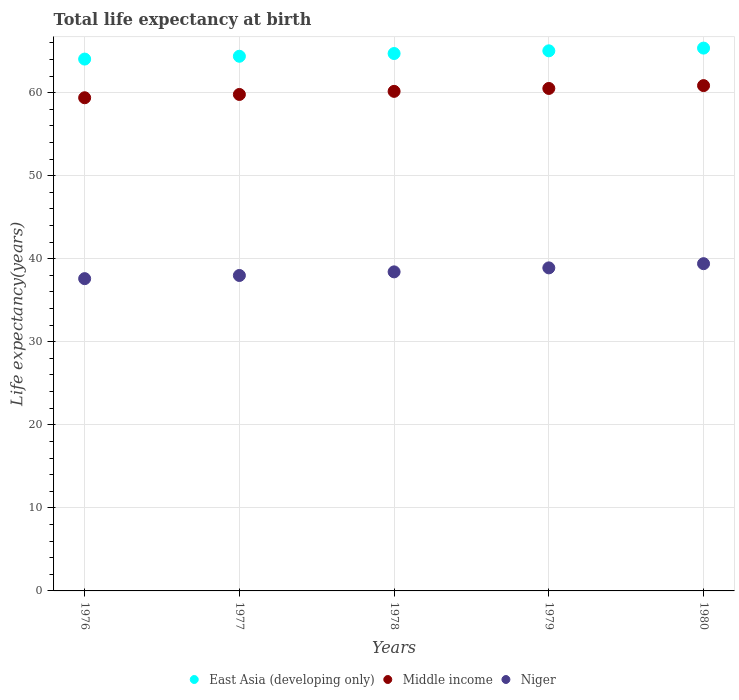Is the number of dotlines equal to the number of legend labels?
Your answer should be very brief. Yes. What is the life expectancy at birth in in Niger in 1979?
Give a very brief answer. 38.9. Across all years, what is the maximum life expectancy at birth in in Middle income?
Your response must be concise. 60.85. Across all years, what is the minimum life expectancy at birth in in Middle income?
Your response must be concise. 59.38. In which year was the life expectancy at birth in in Middle income maximum?
Your answer should be compact. 1980. In which year was the life expectancy at birth in in Middle income minimum?
Offer a very short reply. 1976. What is the total life expectancy at birth in in East Asia (developing only) in the graph?
Keep it short and to the point. 323.53. What is the difference between the life expectancy at birth in in East Asia (developing only) in 1979 and that in 1980?
Offer a very short reply. -0.33. What is the difference between the life expectancy at birth in in Middle income in 1978 and the life expectancy at birth in in East Asia (developing only) in 1976?
Your response must be concise. -3.89. What is the average life expectancy at birth in in Niger per year?
Offer a terse response. 38.46. In the year 1977, what is the difference between the life expectancy at birth in in East Asia (developing only) and life expectancy at birth in in Niger?
Offer a very short reply. 26.4. What is the ratio of the life expectancy at birth in in East Asia (developing only) in 1976 to that in 1978?
Keep it short and to the point. 0.99. Is the life expectancy at birth in in Niger in 1978 less than that in 1979?
Provide a short and direct response. Yes. What is the difference between the highest and the second highest life expectancy at birth in in Middle income?
Offer a terse response. 0.34. What is the difference between the highest and the lowest life expectancy at birth in in Niger?
Give a very brief answer. 1.8. Is the sum of the life expectancy at birth in in East Asia (developing only) in 1977 and 1978 greater than the maximum life expectancy at birth in in Middle income across all years?
Ensure brevity in your answer.  Yes. Does the life expectancy at birth in in Middle income monotonically increase over the years?
Offer a terse response. Yes. Is the life expectancy at birth in in Middle income strictly less than the life expectancy at birth in in East Asia (developing only) over the years?
Offer a very short reply. Yes. How many dotlines are there?
Your answer should be very brief. 3. Does the graph contain any zero values?
Keep it short and to the point. No. Does the graph contain grids?
Provide a short and direct response. Yes. How are the legend labels stacked?
Keep it short and to the point. Horizontal. What is the title of the graph?
Your answer should be very brief. Total life expectancy at birth. Does "Philippines" appear as one of the legend labels in the graph?
Provide a short and direct response. No. What is the label or title of the X-axis?
Provide a succinct answer. Years. What is the label or title of the Y-axis?
Give a very brief answer. Life expectancy(years). What is the Life expectancy(years) of East Asia (developing only) in 1976?
Offer a terse response. 64.04. What is the Life expectancy(years) of Middle income in 1976?
Give a very brief answer. 59.38. What is the Life expectancy(years) of Niger in 1976?
Your answer should be compact. 37.6. What is the Life expectancy(years) in East Asia (developing only) in 1977?
Make the answer very short. 64.38. What is the Life expectancy(years) of Middle income in 1977?
Your response must be concise. 59.78. What is the Life expectancy(years) of Niger in 1977?
Make the answer very short. 37.98. What is the Life expectancy(years) in East Asia (developing only) in 1978?
Give a very brief answer. 64.71. What is the Life expectancy(years) in Middle income in 1978?
Keep it short and to the point. 60.15. What is the Life expectancy(years) of Niger in 1978?
Provide a short and direct response. 38.42. What is the Life expectancy(years) in East Asia (developing only) in 1979?
Provide a short and direct response. 65.03. What is the Life expectancy(years) in Middle income in 1979?
Make the answer very short. 60.5. What is the Life expectancy(years) of Niger in 1979?
Your answer should be compact. 38.9. What is the Life expectancy(years) in East Asia (developing only) in 1980?
Your response must be concise. 65.36. What is the Life expectancy(years) of Middle income in 1980?
Your answer should be compact. 60.85. What is the Life expectancy(years) of Niger in 1980?
Make the answer very short. 39.4. Across all years, what is the maximum Life expectancy(years) in East Asia (developing only)?
Provide a succinct answer. 65.36. Across all years, what is the maximum Life expectancy(years) of Middle income?
Keep it short and to the point. 60.85. Across all years, what is the maximum Life expectancy(years) of Niger?
Give a very brief answer. 39.4. Across all years, what is the minimum Life expectancy(years) in East Asia (developing only)?
Your answer should be very brief. 64.04. Across all years, what is the minimum Life expectancy(years) of Middle income?
Give a very brief answer. 59.38. Across all years, what is the minimum Life expectancy(years) in Niger?
Make the answer very short. 37.6. What is the total Life expectancy(years) in East Asia (developing only) in the graph?
Ensure brevity in your answer.  323.53. What is the total Life expectancy(years) of Middle income in the graph?
Your answer should be compact. 300.67. What is the total Life expectancy(years) of Niger in the graph?
Make the answer very short. 192.3. What is the difference between the Life expectancy(years) in East Asia (developing only) in 1976 and that in 1977?
Your response must be concise. -0.34. What is the difference between the Life expectancy(years) of Middle income in 1976 and that in 1977?
Your response must be concise. -0.4. What is the difference between the Life expectancy(years) of Niger in 1976 and that in 1977?
Your answer should be very brief. -0.38. What is the difference between the Life expectancy(years) in East Asia (developing only) in 1976 and that in 1978?
Offer a very short reply. -0.67. What is the difference between the Life expectancy(years) of Middle income in 1976 and that in 1978?
Ensure brevity in your answer.  -0.77. What is the difference between the Life expectancy(years) of Niger in 1976 and that in 1978?
Provide a succinct answer. -0.82. What is the difference between the Life expectancy(years) of East Asia (developing only) in 1976 and that in 1979?
Offer a terse response. -0.99. What is the difference between the Life expectancy(years) in Middle income in 1976 and that in 1979?
Offer a terse response. -1.12. What is the difference between the Life expectancy(years) of Niger in 1976 and that in 1979?
Your answer should be compact. -1.3. What is the difference between the Life expectancy(years) in East Asia (developing only) in 1976 and that in 1980?
Your answer should be very brief. -1.32. What is the difference between the Life expectancy(years) in Middle income in 1976 and that in 1980?
Your answer should be very brief. -1.46. What is the difference between the Life expectancy(years) of Niger in 1976 and that in 1980?
Provide a short and direct response. -1.8. What is the difference between the Life expectancy(years) in East Asia (developing only) in 1977 and that in 1978?
Provide a short and direct response. -0.33. What is the difference between the Life expectancy(years) of Middle income in 1977 and that in 1978?
Your answer should be compact. -0.37. What is the difference between the Life expectancy(years) of Niger in 1977 and that in 1978?
Provide a succinct answer. -0.43. What is the difference between the Life expectancy(years) in East Asia (developing only) in 1977 and that in 1979?
Ensure brevity in your answer.  -0.66. What is the difference between the Life expectancy(years) in Middle income in 1977 and that in 1979?
Your answer should be very brief. -0.72. What is the difference between the Life expectancy(years) in Niger in 1977 and that in 1979?
Your answer should be compact. -0.91. What is the difference between the Life expectancy(years) in East Asia (developing only) in 1977 and that in 1980?
Your answer should be compact. -0.98. What is the difference between the Life expectancy(years) in Middle income in 1977 and that in 1980?
Keep it short and to the point. -1.06. What is the difference between the Life expectancy(years) in Niger in 1977 and that in 1980?
Offer a very short reply. -1.42. What is the difference between the Life expectancy(years) in East Asia (developing only) in 1978 and that in 1979?
Your response must be concise. -0.33. What is the difference between the Life expectancy(years) in Middle income in 1978 and that in 1979?
Keep it short and to the point. -0.35. What is the difference between the Life expectancy(years) in Niger in 1978 and that in 1979?
Your response must be concise. -0.48. What is the difference between the Life expectancy(years) of East Asia (developing only) in 1978 and that in 1980?
Your answer should be very brief. -0.65. What is the difference between the Life expectancy(years) in Middle income in 1978 and that in 1980?
Your answer should be very brief. -0.69. What is the difference between the Life expectancy(years) in Niger in 1978 and that in 1980?
Give a very brief answer. -0.99. What is the difference between the Life expectancy(years) in East Asia (developing only) in 1979 and that in 1980?
Provide a succinct answer. -0.33. What is the difference between the Life expectancy(years) of Middle income in 1979 and that in 1980?
Offer a terse response. -0.34. What is the difference between the Life expectancy(years) of Niger in 1979 and that in 1980?
Offer a very short reply. -0.51. What is the difference between the Life expectancy(years) in East Asia (developing only) in 1976 and the Life expectancy(years) in Middle income in 1977?
Your answer should be compact. 4.26. What is the difference between the Life expectancy(years) in East Asia (developing only) in 1976 and the Life expectancy(years) in Niger in 1977?
Make the answer very short. 26.06. What is the difference between the Life expectancy(years) in Middle income in 1976 and the Life expectancy(years) in Niger in 1977?
Offer a very short reply. 21.4. What is the difference between the Life expectancy(years) of East Asia (developing only) in 1976 and the Life expectancy(years) of Middle income in 1978?
Offer a terse response. 3.89. What is the difference between the Life expectancy(years) of East Asia (developing only) in 1976 and the Life expectancy(years) of Niger in 1978?
Make the answer very short. 25.62. What is the difference between the Life expectancy(years) in Middle income in 1976 and the Life expectancy(years) in Niger in 1978?
Give a very brief answer. 20.97. What is the difference between the Life expectancy(years) of East Asia (developing only) in 1976 and the Life expectancy(years) of Middle income in 1979?
Your answer should be very brief. 3.54. What is the difference between the Life expectancy(years) in East Asia (developing only) in 1976 and the Life expectancy(years) in Niger in 1979?
Give a very brief answer. 25.14. What is the difference between the Life expectancy(years) of Middle income in 1976 and the Life expectancy(years) of Niger in 1979?
Ensure brevity in your answer.  20.49. What is the difference between the Life expectancy(years) of East Asia (developing only) in 1976 and the Life expectancy(years) of Middle income in 1980?
Ensure brevity in your answer.  3.2. What is the difference between the Life expectancy(years) of East Asia (developing only) in 1976 and the Life expectancy(years) of Niger in 1980?
Make the answer very short. 24.64. What is the difference between the Life expectancy(years) of Middle income in 1976 and the Life expectancy(years) of Niger in 1980?
Provide a short and direct response. 19.98. What is the difference between the Life expectancy(years) of East Asia (developing only) in 1977 and the Life expectancy(years) of Middle income in 1978?
Keep it short and to the point. 4.23. What is the difference between the Life expectancy(years) in East Asia (developing only) in 1977 and the Life expectancy(years) in Niger in 1978?
Your response must be concise. 25.96. What is the difference between the Life expectancy(years) of Middle income in 1977 and the Life expectancy(years) of Niger in 1978?
Offer a terse response. 21.36. What is the difference between the Life expectancy(years) in East Asia (developing only) in 1977 and the Life expectancy(years) in Middle income in 1979?
Your answer should be very brief. 3.88. What is the difference between the Life expectancy(years) in East Asia (developing only) in 1977 and the Life expectancy(years) in Niger in 1979?
Ensure brevity in your answer.  25.48. What is the difference between the Life expectancy(years) of Middle income in 1977 and the Life expectancy(years) of Niger in 1979?
Your answer should be compact. 20.88. What is the difference between the Life expectancy(years) in East Asia (developing only) in 1977 and the Life expectancy(years) in Middle income in 1980?
Your response must be concise. 3.53. What is the difference between the Life expectancy(years) of East Asia (developing only) in 1977 and the Life expectancy(years) of Niger in 1980?
Make the answer very short. 24.98. What is the difference between the Life expectancy(years) of Middle income in 1977 and the Life expectancy(years) of Niger in 1980?
Keep it short and to the point. 20.38. What is the difference between the Life expectancy(years) in East Asia (developing only) in 1978 and the Life expectancy(years) in Middle income in 1979?
Ensure brevity in your answer.  4.21. What is the difference between the Life expectancy(years) in East Asia (developing only) in 1978 and the Life expectancy(years) in Niger in 1979?
Offer a terse response. 25.81. What is the difference between the Life expectancy(years) in Middle income in 1978 and the Life expectancy(years) in Niger in 1979?
Your answer should be compact. 21.25. What is the difference between the Life expectancy(years) in East Asia (developing only) in 1978 and the Life expectancy(years) in Middle income in 1980?
Keep it short and to the point. 3.86. What is the difference between the Life expectancy(years) of East Asia (developing only) in 1978 and the Life expectancy(years) of Niger in 1980?
Provide a short and direct response. 25.31. What is the difference between the Life expectancy(years) of Middle income in 1978 and the Life expectancy(years) of Niger in 1980?
Make the answer very short. 20.75. What is the difference between the Life expectancy(years) of East Asia (developing only) in 1979 and the Life expectancy(years) of Middle income in 1980?
Your response must be concise. 4.19. What is the difference between the Life expectancy(years) of East Asia (developing only) in 1979 and the Life expectancy(years) of Niger in 1980?
Offer a terse response. 25.63. What is the difference between the Life expectancy(years) of Middle income in 1979 and the Life expectancy(years) of Niger in 1980?
Ensure brevity in your answer.  21.1. What is the average Life expectancy(years) of East Asia (developing only) per year?
Keep it short and to the point. 64.71. What is the average Life expectancy(years) in Middle income per year?
Offer a terse response. 60.13. What is the average Life expectancy(years) in Niger per year?
Offer a terse response. 38.46. In the year 1976, what is the difference between the Life expectancy(years) in East Asia (developing only) and Life expectancy(years) in Middle income?
Your response must be concise. 4.66. In the year 1976, what is the difference between the Life expectancy(years) in East Asia (developing only) and Life expectancy(years) in Niger?
Provide a short and direct response. 26.44. In the year 1976, what is the difference between the Life expectancy(years) in Middle income and Life expectancy(years) in Niger?
Offer a terse response. 21.78. In the year 1977, what is the difference between the Life expectancy(years) of East Asia (developing only) and Life expectancy(years) of Middle income?
Your response must be concise. 4.6. In the year 1977, what is the difference between the Life expectancy(years) in East Asia (developing only) and Life expectancy(years) in Niger?
Your response must be concise. 26.4. In the year 1977, what is the difference between the Life expectancy(years) of Middle income and Life expectancy(years) of Niger?
Offer a terse response. 21.8. In the year 1978, what is the difference between the Life expectancy(years) in East Asia (developing only) and Life expectancy(years) in Middle income?
Make the answer very short. 4.56. In the year 1978, what is the difference between the Life expectancy(years) of East Asia (developing only) and Life expectancy(years) of Niger?
Give a very brief answer. 26.29. In the year 1978, what is the difference between the Life expectancy(years) in Middle income and Life expectancy(years) in Niger?
Keep it short and to the point. 21.73. In the year 1979, what is the difference between the Life expectancy(years) in East Asia (developing only) and Life expectancy(years) in Middle income?
Ensure brevity in your answer.  4.53. In the year 1979, what is the difference between the Life expectancy(years) in East Asia (developing only) and Life expectancy(years) in Niger?
Provide a short and direct response. 26.14. In the year 1979, what is the difference between the Life expectancy(years) in Middle income and Life expectancy(years) in Niger?
Your response must be concise. 21.6. In the year 1980, what is the difference between the Life expectancy(years) in East Asia (developing only) and Life expectancy(years) in Middle income?
Your response must be concise. 4.52. In the year 1980, what is the difference between the Life expectancy(years) in East Asia (developing only) and Life expectancy(years) in Niger?
Make the answer very short. 25.96. In the year 1980, what is the difference between the Life expectancy(years) in Middle income and Life expectancy(years) in Niger?
Provide a short and direct response. 21.44. What is the ratio of the Life expectancy(years) of East Asia (developing only) in 1976 to that in 1977?
Provide a succinct answer. 0.99. What is the ratio of the Life expectancy(years) of Middle income in 1976 to that in 1977?
Your answer should be very brief. 0.99. What is the ratio of the Life expectancy(years) of Niger in 1976 to that in 1977?
Keep it short and to the point. 0.99. What is the ratio of the Life expectancy(years) in East Asia (developing only) in 1976 to that in 1978?
Provide a short and direct response. 0.99. What is the ratio of the Life expectancy(years) in Middle income in 1976 to that in 1978?
Ensure brevity in your answer.  0.99. What is the ratio of the Life expectancy(years) of Niger in 1976 to that in 1978?
Give a very brief answer. 0.98. What is the ratio of the Life expectancy(years) of East Asia (developing only) in 1976 to that in 1979?
Provide a short and direct response. 0.98. What is the ratio of the Life expectancy(years) of Middle income in 1976 to that in 1979?
Your answer should be compact. 0.98. What is the ratio of the Life expectancy(years) of Niger in 1976 to that in 1979?
Your response must be concise. 0.97. What is the ratio of the Life expectancy(years) in East Asia (developing only) in 1976 to that in 1980?
Offer a very short reply. 0.98. What is the ratio of the Life expectancy(years) in Niger in 1976 to that in 1980?
Offer a terse response. 0.95. What is the ratio of the Life expectancy(years) of Middle income in 1977 to that in 1978?
Ensure brevity in your answer.  0.99. What is the ratio of the Life expectancy(years) in Niger in 1977 to that in 1978?
Your answer should be compact. 0.99. What is the ratio of the Life expectancy(years) of Niger in 1977 to that in 1979?
Offer a very short reply. 0.98. What is the ratio of the Life expectancy(years) in East Asia (developing only) in 1977 to that in 1980?
Give a very brief answer. 0.98. What is the ratio of the Life expectancy(years) in Middle income in 1977 to that in 1980?
Your response must be concise. 0.98. What is the ratio of the Life expectancy(years) of Niger in 1977 to that in 1980?
Offer a terse response. 0.96. What is the ratio of the Life expectancy(years) in Middle income in 1978 to that in 1979?
Provide a succinct answer. 0.99. What is the ratio of the Life expectancy(years) of Niger in 1978 to that in 1979?
Your response must be concise. 0.99. What is the ratio of the Life expectancy(years) of Niger in 1979 to that in 1980?
Ensure brevity in your answer.  0.99. What is the difference between the highest and the second highest Life expectancy(years) in East Asia (developing only)?
Give a very brief answer. 0.33. What is the difference between the highest and the second highest Life expectancy(years) in Middle income?
Make the answer very short. 0.34. What is the difference between the highest and the second highest Life expectancy(years) of Niger?
Provide a succinct answer. 0.51. What is the difference between the highest and the lowest Life expectancy(years) in East Asia (developing only)?
Provide a succinct answer. 1.32. What is the difference between the highest and the lowest Life expectancy(years) of Middle income?
Provide a short and direct response. 1.46. What is the difference between the highest and the lowest Life expectancy(years) of Niger?
Keep it short and to the point. 1.8. 